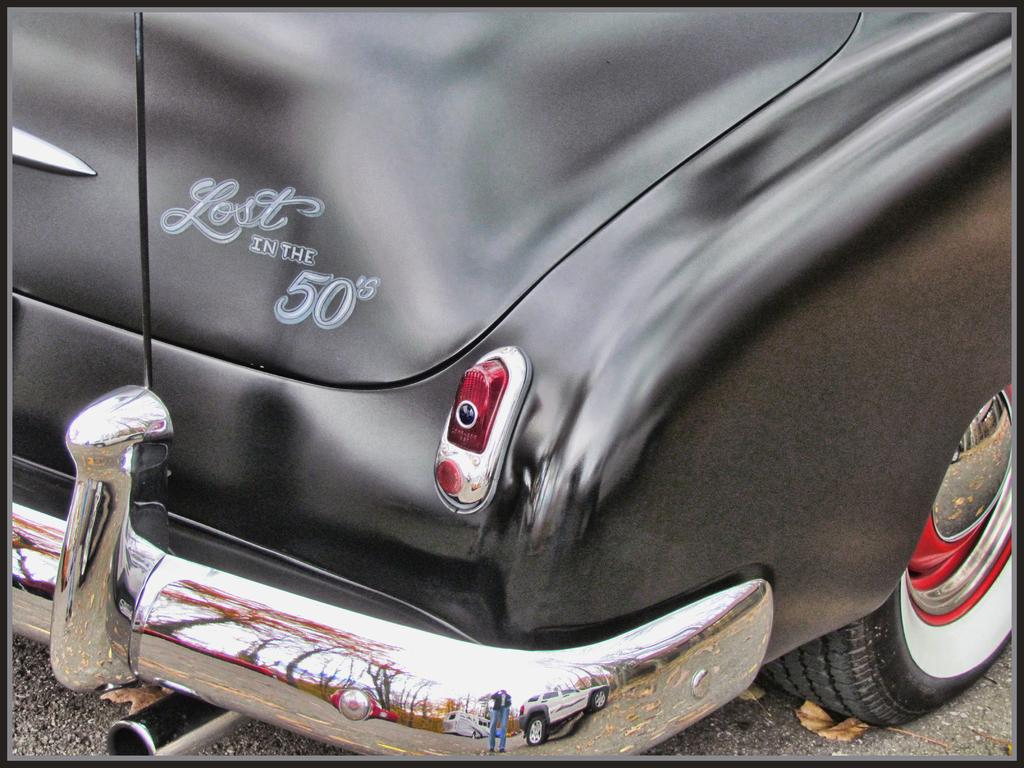What color is the car in the image? The car in the image is black. Are there any markings or text on the car? Yes, there is text on the car. What can be seen in the background of the image? There is a road visible in the image. What is present on the road in the image? Dry leaves are present on the road. What type of pest can be seen crawling on the car in the image? There are no pests visible on the car in the image. What religious symbols are present on the car in the image? There is no information about religious symbols on the car in the image. 